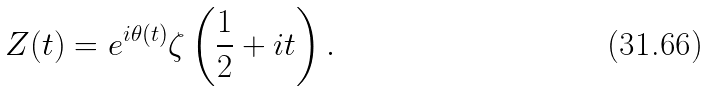<formula> <loc_0><loc_0><loc_500><loc_500>Z ( t ) = e ^ { i \theta ( t ) } \zeta \left ( { \frac { 1 } { 2 } } + i t \right ) .</formula> 